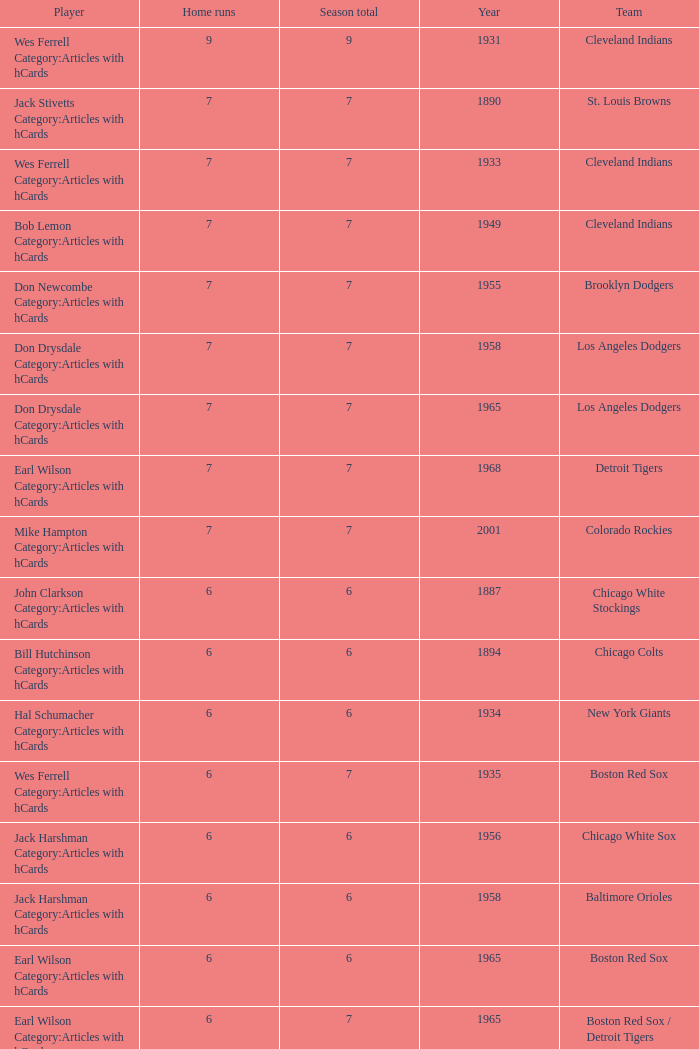State the top home runs for cleveland indians before the year 193 None. 